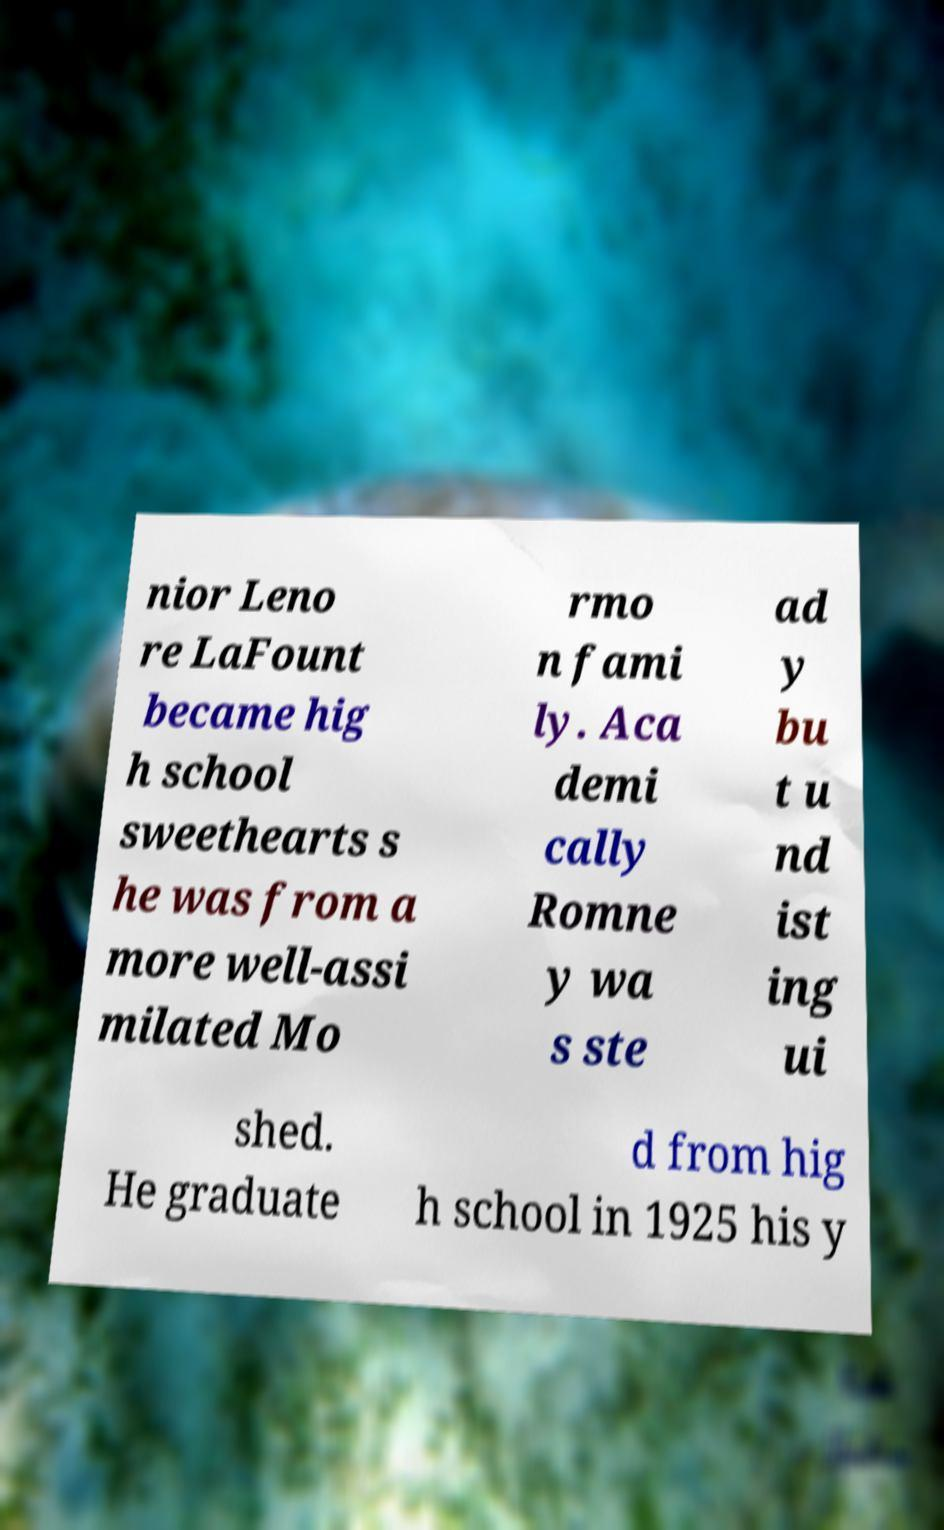Can you accurately transcribe the text from the provided image for me? nior Leno re LaFount became hig h school sweethearts s he was from a more well-assi milated Mo rmo n fami ly. Aca demi cally Romne y wa s ste ad y bu t u nd ist ing ui shed. He graduate d from hig h school in 1925 his y 